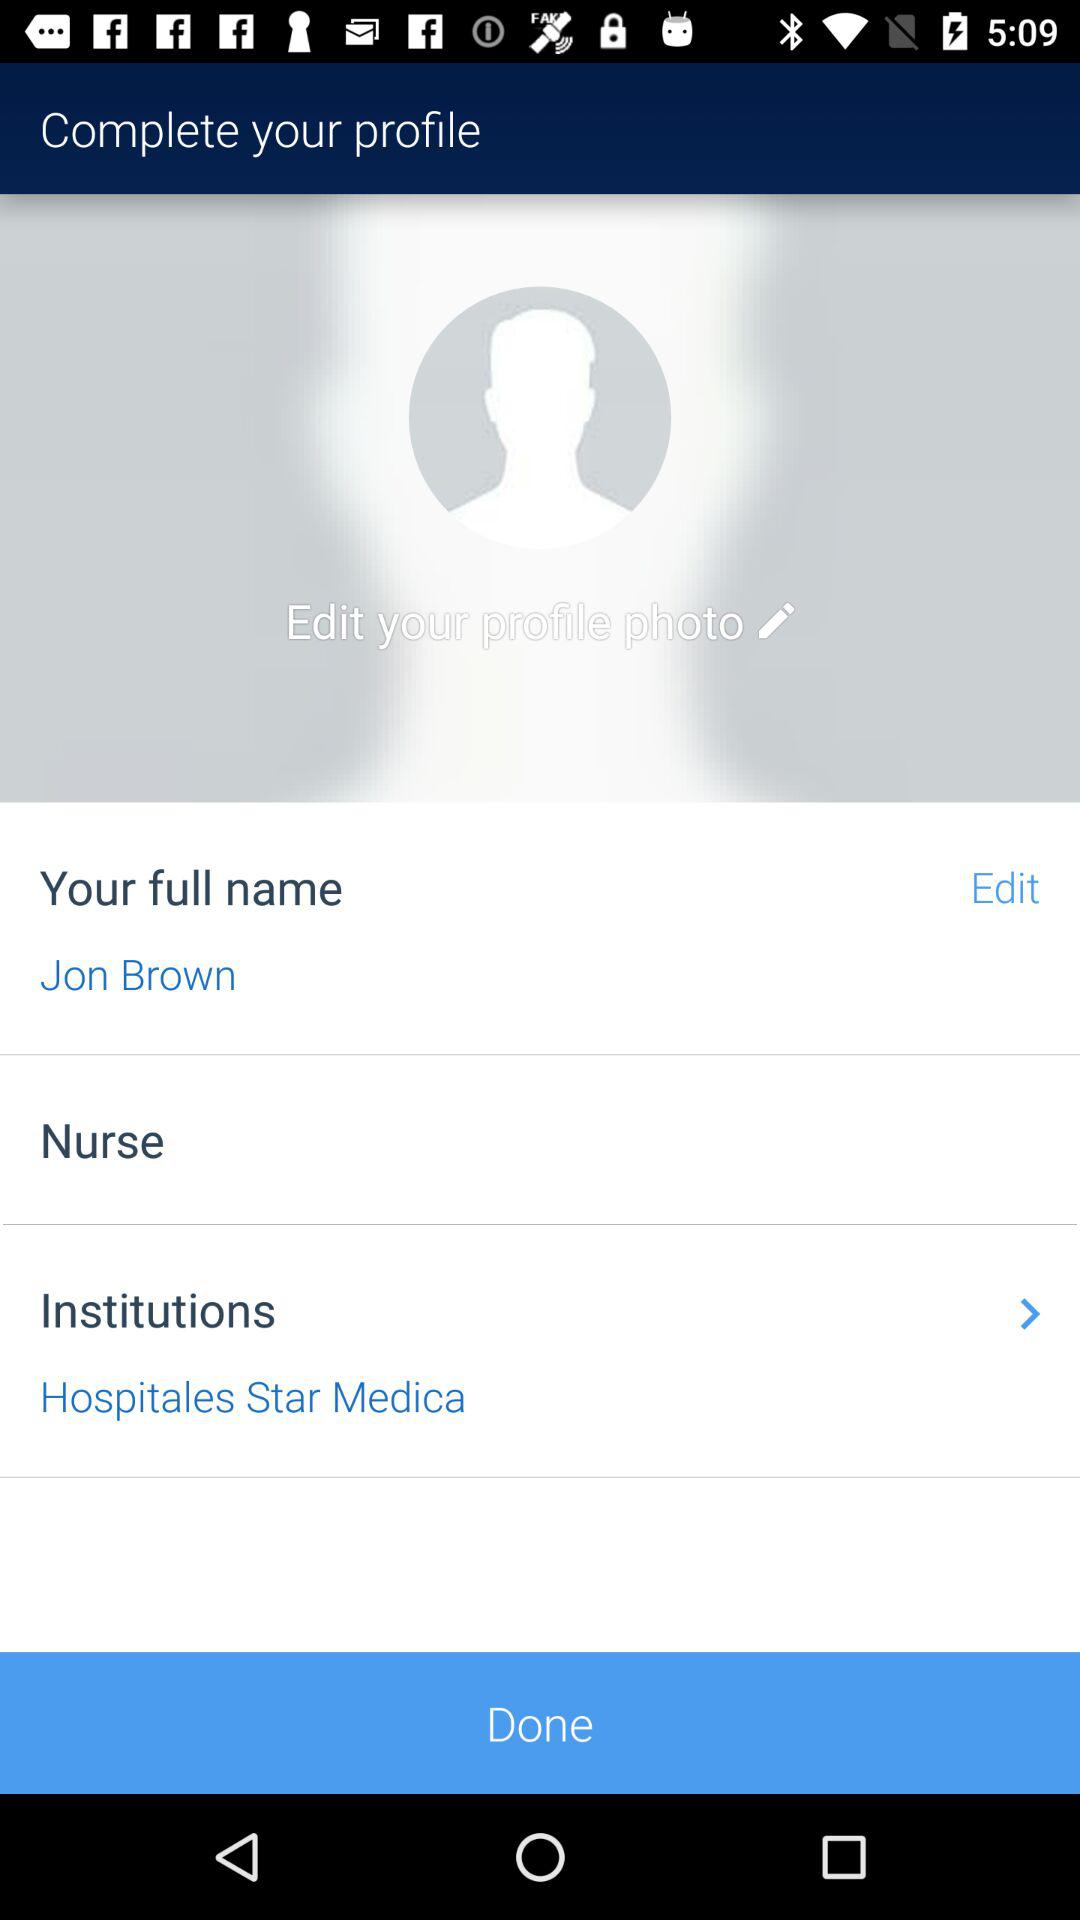What is the name of the user? The name of the user is Jon Brown. 